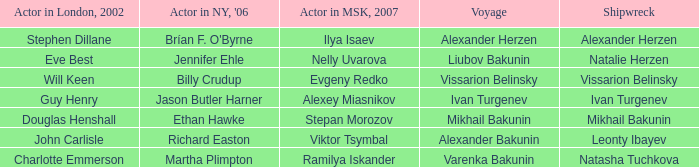Who was the actor in Moscow who did the part done by John Carlisle in London in 2002? Viktor Tsymbal. 